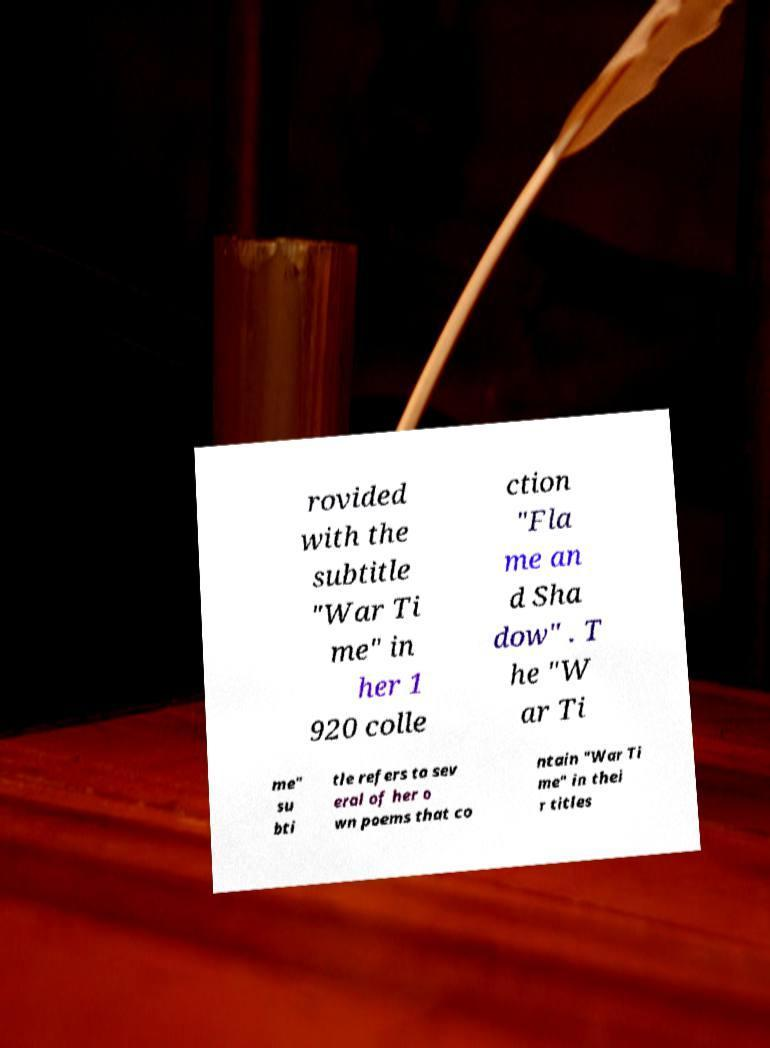Can you accurately transcribe the text from the provided image for me? rovided with the subtitle "War Ti me" in her 1 920 colle ction "Fla me an d Sha dow" . T he "W ar Ti me" su bti tle refers to sev eral of her o wn poems that co ntain "War Ti me" in thei r titles 